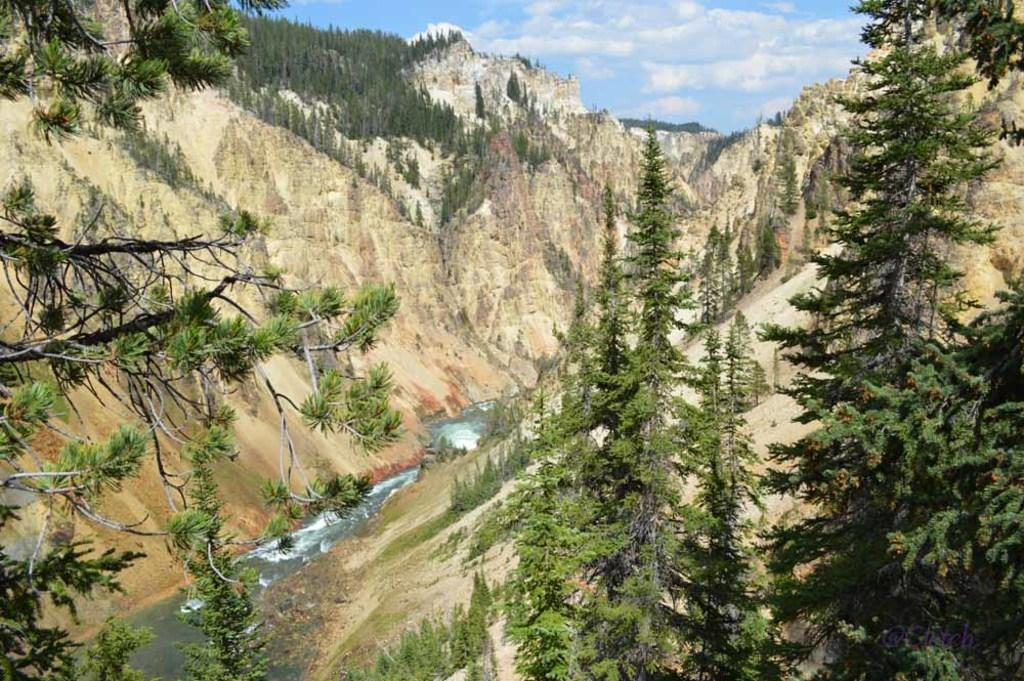What type of natural feature is the main subject of the image? There is a river in the image. What surrounds the river in the image? Mountains are present on both sides of the river. What type of vegetation can be seen on the mountains? Trees are present on the mountains. What is visible at the top of the image? The sky is visible at the top of the image. What can be seen in the sky? Clouds are present in the sky. What type of bell can be heard ringing in the image? There is no bell present in the image, and therefore no sound can be heard. 